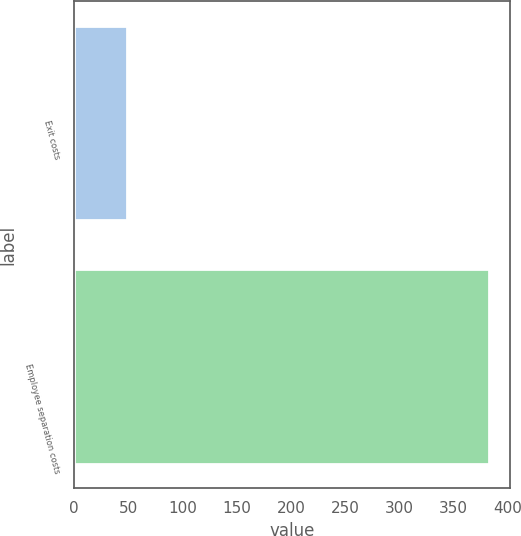<chart> <loc_0><loc_0><loc_500><loc_500><bar_chart><fcel>Exit costs<fcel>Employee separation costs<nl><fcel>49<fcel>383<nl></chart> 